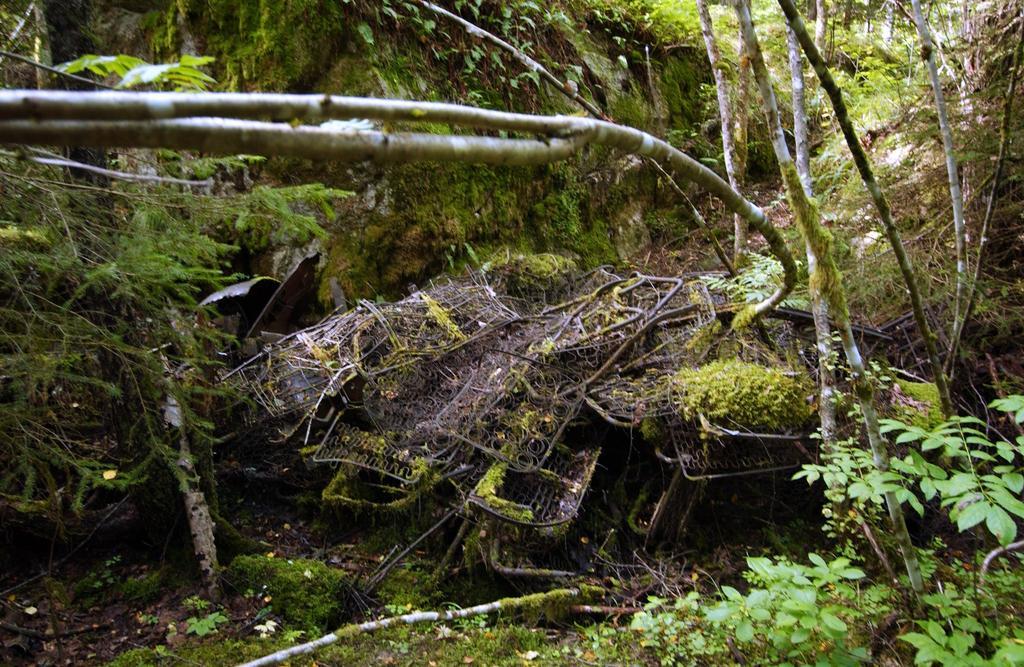Describe this image in one or two sentences. As we can see in the image there is grass, plants and trees. 